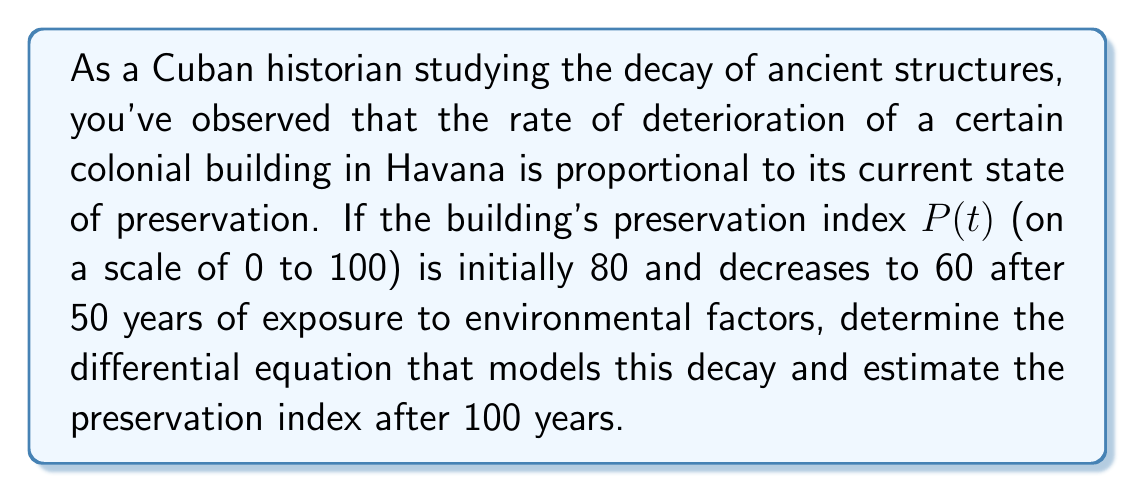Can you answer this question? Let's approach this step-by-step:

1) The rate of change of the preservation index is proportional to its current value. This can be expressed as:

   $$\frac{dP}{dt} = -kP$$

   where $k$ is the decay constant and the negative sign indicates decay.

2) We can solve this differential equation:

   $$\int \frac{dP}{P} = -k \int dt$$
   $$\ln|P| = -kt + C$$
   $$P = Ae^{-kt}$$

   where $A$ is the initial preservation index.

3) We know that:
   - At $t = 0$, $P = 80$, so $A = 80$
   - At $t = 50$, $P = 60$

4) We can use these conditions to find $k$:

   $$60 = 80e^{-50k}$$
   $$\frac{60}{80} = e^{-50k}$$
   $$\ln(\frac{3}{4}) = -50k$$
   $$k = \frac{\ln(\frac{4}{3})}{50} \approx 0.00579$$

5) Now we have our complete model:

   $$P = 80e^{-0.00579t}$$

6) To find the preservation index after 100 years, we substitute $t = 100$:

   $$P(100) = 80e^{-0.00579 \cdot 100} \approx 44.93$$

Therefore, after 100 years, the preservation index will be approximately 44.93.
Answer: The differential equation modeling the decay is $\frac{dP}{dt} = -0.00579P$, and the preservation index after 100 years is approximately 44.93. 